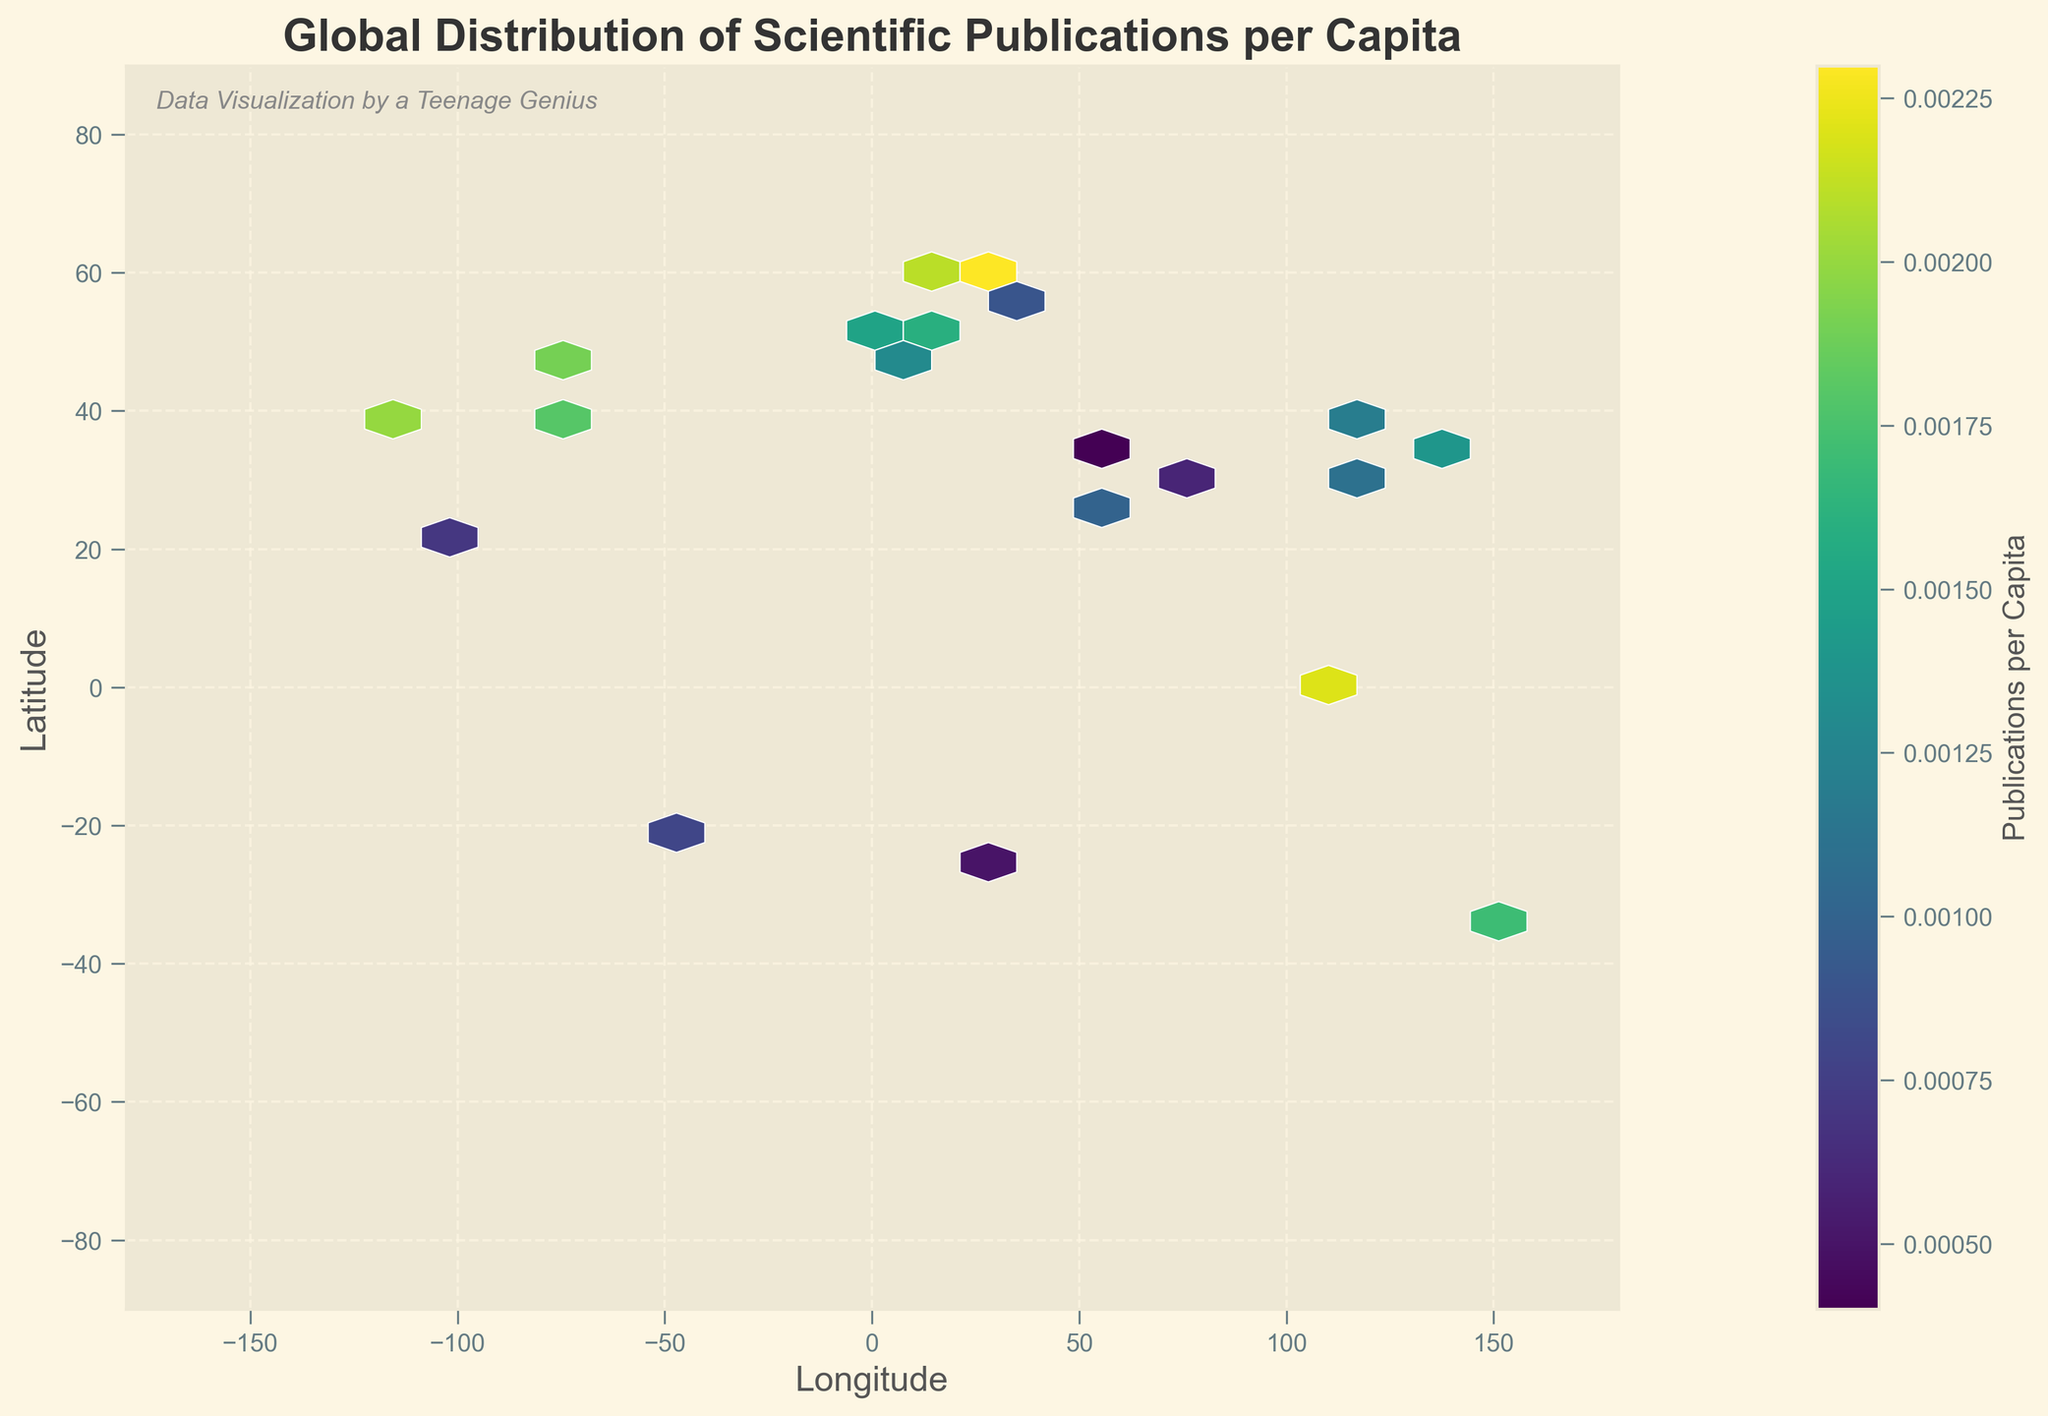What is the title of the plot? The plot has a title at the top, which reads "Global Distribution of Scientific Publications per Capita."
Answer: Global Distribution of Scientific Publications per Capita What is the color representing in this hexbin plot? The color in the hexbin plot represents the number of scientific publications per capita, as indicated by the color bar on the right side of the plot.
Answer: Publications per Capita Which axis represents latitude? The y-axis of the plot is labeled with "Latitude," indicating that this axis represents latitude.
Answer: y-axis Does the plot include grid lines? The plot has grid lines, which are visible as dashed lines running across the background. They are semi-transparent and add visual reference points.
Answer: Yes Which city has the highest publications per capita, based on color intensity? According to the color intensity, the area around Helsinki, Finland (60.1699, 24.9384) has the highest publications per capita. This location has the most intense (brightest) color on the plot.
Answer: Helsinki, Finland Between Europe and North America, which continent has a denser distribution of scientific publications per capita? By examining the color intensity and the number of hexagons in both regions, Europe appears to have a denser distribution of scientific publications per capita, especially around cities like London, Berlin, and Paris.
Answer: Europe What can be inferred about scientific publications per capita in the Southern Hemisphere? The regions in the Southern Hemisphere, such as parts of Australia and Brazil, have fewer and less densely packed hexagons, indicating lower scientific publications per capita compared to the Northern Hemisphere.
Answer: Lower Which city in Asia shows a relatively high number of publications per capita? Among the Asian cities, Singapore (1.3521, 103.8198) displays the highest number of publications per capita, as indicated by its bright color.
Answer: Singapore How does the publication activity in South America compare to that in North America? South America, particularly near São Paulo, Brazil, shows significantly lower publication activity per capita compared to North American cities like New York and San Francisco, which have more intense color areas.
Answer: Lower If you were to visit the top three research hotspots globally based on this plot, which cities would you choose? Based on the brightest hexagons, you would visit San Francisco, USA (37.7749, -122.4194), Singapore (1.3521, 103.8198), and Helsinki, Finland (60.1699, 24.9384), as these cities have the highest publications per capita.
Answer: San Francisco, Singapore, Helsinki 